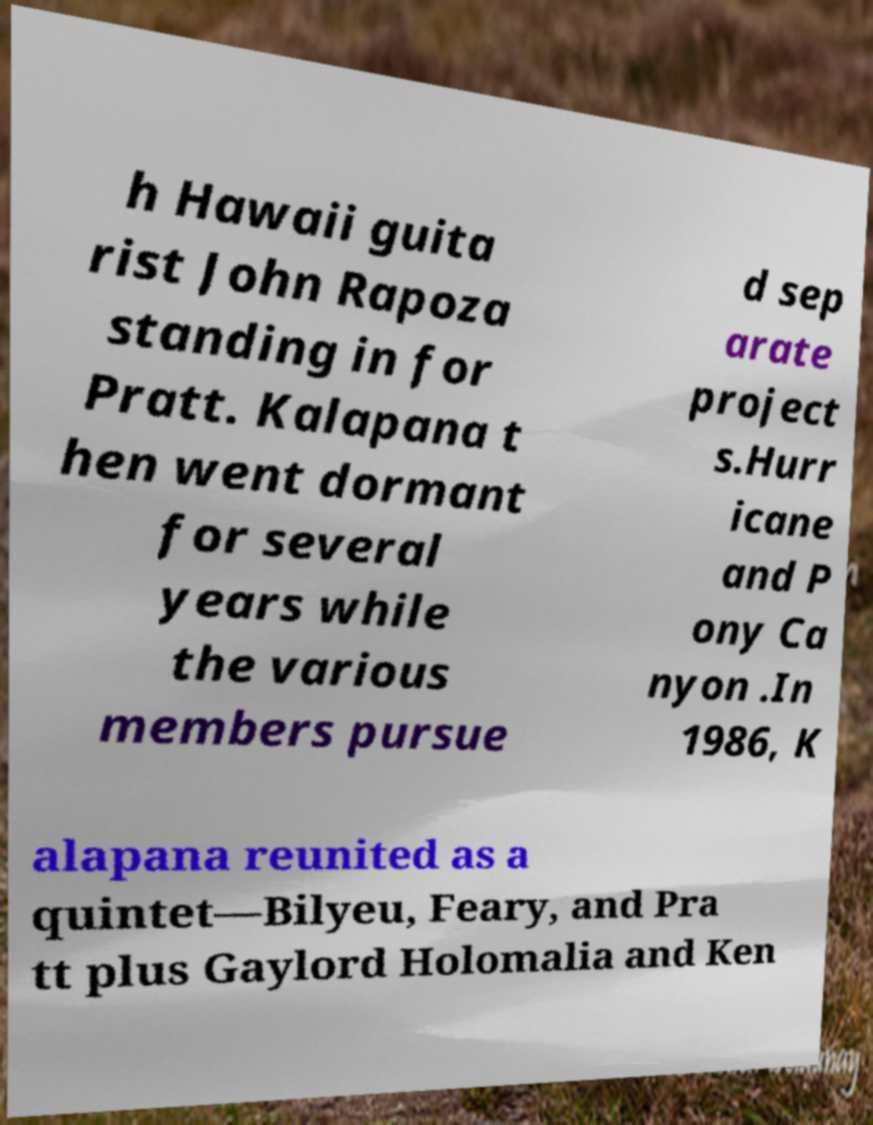Please read and relay the text visible in this image. What does it say? h Hawaii guita rist John Rapoza standing in for Pratt. Kalapana t hen went dormant for several years while the various members pursue d sep arate project s.Hurr icane and P ony Ca nyon .In 1986, K alapana reunited as a quintet—Bilyeu, Feary, and Pra tt plus Gaylord Holomalia and Ken 